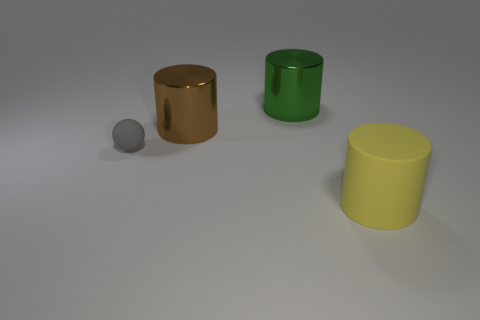How many spheres are brown metallic objects or small blue objects?
Give a very brief answer. 0. What number of rubber objects are both to the right of the big green cylinder and on the left side of the big rubber cylinder?
Your answer should be compact. 0. What number of other objects are the same color as the small object?
Offer a very short reply. 0. There is a shiny object on the left side of the large green cylinder; what is its shape?
Your answer should be very brief. Cylinder. Is the tiny thing made of the same material as the big yellow object?
Offer a very short reply. Yes. Are there any other things that are the same size as the matte ball?
Your answer should be very brief. No. There is a gray matte sphere; how many large brown cylinders are on the left side of it?
Keep it short and to the point. 0. What shape is the rubber thing that is behind the large yellow rubber cylinder to the right of the green object?
Your answer should be very brief. Sphere. Is there any other thing that is the same shape as the small matte object?
Make the answer very short. No. Are there more big brown metallic cylinders in front of the big green object than small brown blocks?
Your answer should be very brief. Yes. 